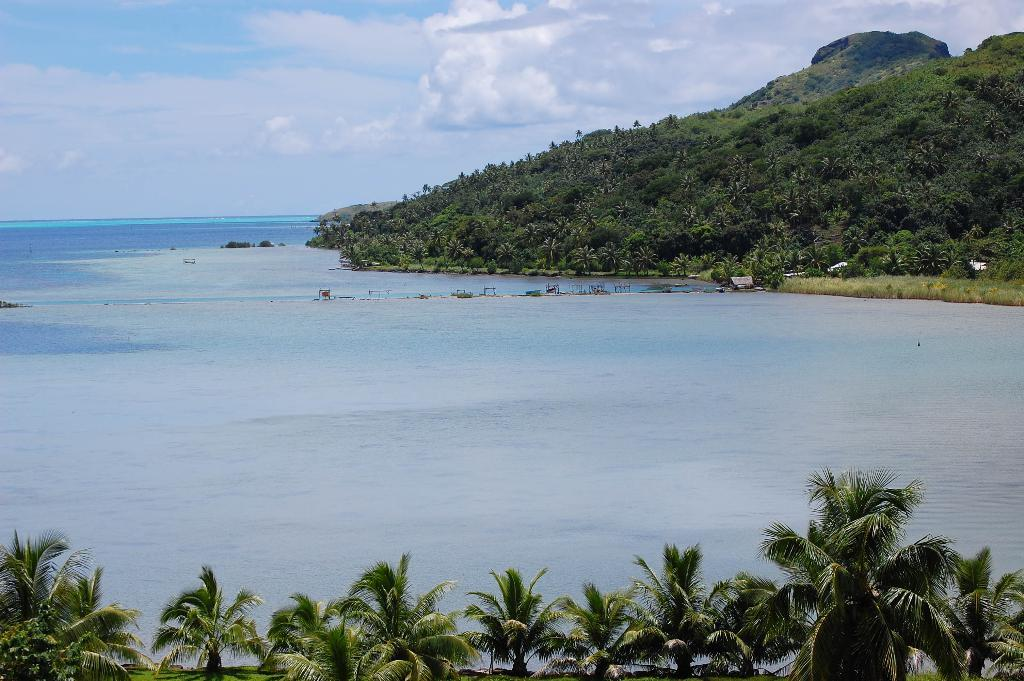What is located in the foreground of the picture? There are trees in the foreground of the picture. What can be seen in the center of the picture? There is a water body in the center of the picture. What is visible in the background of the picture? There is a hill covered with trees in the background. How would you describe the sky in the picture? The sky is partially cloudy. What type of ball is being played with on the hill in the background? There is no ball present in the image; the hill is covered with trees. Can you see a wren perched on any of the trees in the foreground? There is no wren visible in the image; only trees are present in the foreground. 